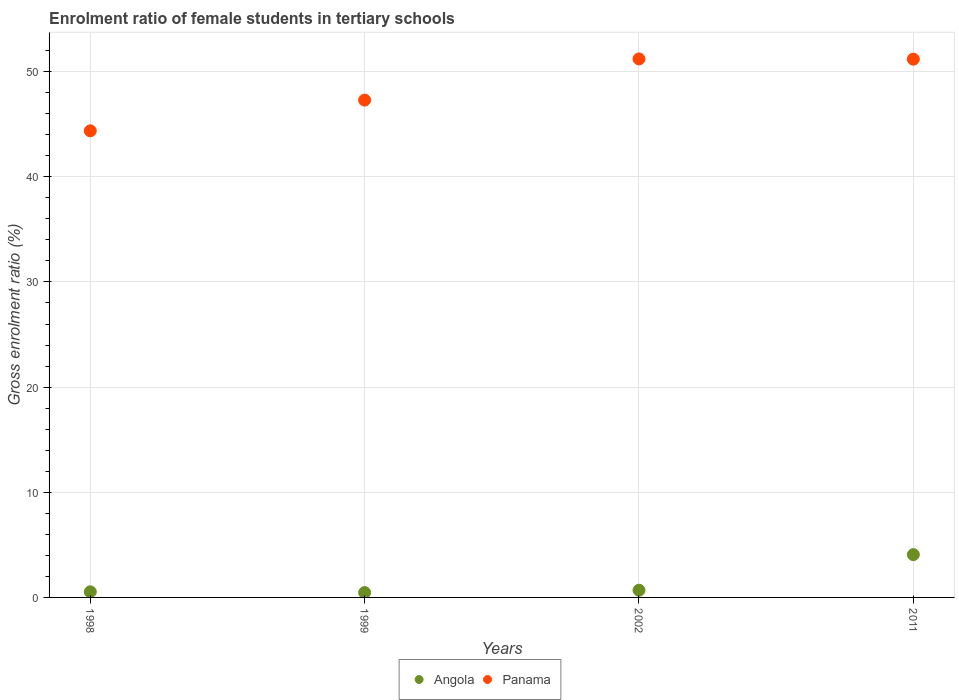How many different coloured dotlines are there?
Your answer should be very brief. 2. What is the enrolment ratio of female students in tertiary schools in Angola in 2011?
Offer a terse response. 4.07. Across all years, what is the maximum enrolment ratio of female students in tertiary schools in Panama?
Offer a very short reply. 51.21. Across all years, what is the minimum enrolment ratio of female students in tertiary schools in Panama?
Ensure brevity in your answer.  44.37. In which year was the enrolment ratio of female students in tertiary schools in Panama maximum?
Offer a terse response. 2002. What is the total enrolment ratio of female students in tertiary schools in Panama in the graph?
Ensure brevity in your answer.  194.06. What is the difference between the enrolment ratio of female students in tertiary schools in Panama in 1998 and that in 2011?
Offer a terse response. -6.81. What is the difference between the enrolment ratio of female students in tertiary schools in Panama in 2011 and the enrolment ratio of female students in tertiary schools in Angola in 1999?
Offer a terse response. 50.72. What is the average enrolment ratio of female students in tertiary schools in Angola per year?
Provide a short and direct response. 1.44. In the year 1999, what is the difference between the enrolment ratio of female students in tertiary schools in Panama and enrolment ratio of female students in tertiary schools in Angola?
Your answer should be very brief. 46.83. What is the ratio of the enrolment ratio of female students in tertiary schools in Panama in 1998 to that in 2011?
Offer a terse response. 0.87. Is the difference between the enrolment ratio of female students in tertiary schools in Panama in 1998 and 2011 greater than the difference between the enrolment ratio of female students in tertiary schools in Angola in 1998 and 2011?
Make the answer very short. No. What is the difference between the highest and the second highest enrolment ratio of female students in tertiary schools in Panama?
Your answer should be very brief. 0.02. What is the difference between the highest and the lowest enrolment ratio of female students in tertiary schools in Panama?
Keep it short and to the point. 6.84. In how many years, is the enrolment ratio of female students in tertiary schools in Angola greater than the average enrolment ratio of female students in tertiary schools in Angola taken over all years?
Keep it short and to the point. 1. Does the enrolment ratio of female students in tertiary schools in Panama monotonically increase over the years?
Provide a short and direct response. No. Is the enrolment ratio of female students in tertiary schools in Panama strictly less than the enrolment ratio of female students in tertiary schools in Angola over the years?
Your answer should be compact. No. How many dotlines are there?
Provide a succinct answer. 2. Does the graph contain grids?
Offer a terse response. Yes. How are the legend labels stacked?
Ensure brevity in your answer.  Horizontal. What is the title of the graph?
Make the answer very short. Enrolment ratio of female students in tertiary schools. Does "Italy" appear as one of the legend labels in the graph?
Keep it short and to the point. No. What is the Gross enrolment ratio (%) in Angola in 1998?
Keep it short and to the point. 0.53. What is the Gross enrolment ratio (%) in Panama in 1998?
Make the answer very short. 44.37. What is the Gross enrolment ratio (%) of Angola in 1999?
Your response must be concise. 0.46. What is the Gross enrolment ratio (%) in Panama in 1999?
Provide a short and direct response. 47.29. What is the Gross enrolment ratio (%) in Angola in 2002?
Offer a terse response. 0.68. What is the Gross enrolment ratio (%) of Panama in 2002?
Provide a succinct answer. 51.21. What is the Gross enrolment ratio (%) in Angola in 2011?
Keep it short and to the point. 4.07. What is the Gross enrolment ratio (%) of Panama in 2011?
Your answer should be compact. 51.19. Across all years, what is the maximum Gross enrolment ratio (%) in Angola?
Your answer should be compact. 4.07. Across all years, what is the maximum Gross enrolment ratio (%) in Panama?
Give a very brief answer. 51.21. Across all years, what is the minimum Gross enrolment ratio (%) of Angola?
Keep it short and to the point. 0.46. Across all years, what is the minimum Gross enrolment ratio (%) in Panama?
Give a very brief answer. 44.37. What is the total Gross enrolment ratio (%) in Angola in the graph?
Your response must be concise. 5.75. What is the total Gross enrolment ratio (%) in Panama in the graph?
Offer a terse response. 194.06. What is the difference between the Gross enrolment ratio (%) in Angola in 1998 and that in 1999?
Keep it short and to the point. 0.07. What is the difference between the Gross enrolment ratio (%) in Panama in 1998 and that in 1999?
Your answer should be very brief. -2.92. What is the difference between the Gross enrolment ratio (%) of Angola in 1998 and that in 2002?
Provide a short and direct response. -0.15. What is the difference between the Gross enrolment ratio (%) of Panama in 1998 and that in 2002?
Your answer should be very brief. -6.84. What is the difference between the Gross enrolment ratio (%) in Angola in 1998 and that in 2011?
Your answer should be compact. -3.53. What is the difference between the Gross enrolment ratio (%) of Panama in 1998 and that in 2011?
Your answer should be compact. -6.81. What is the difference between the Gross enrolment ratio (%) of Angola in 1999 and that in 2002?
Offer a very short reply. -0.22. What is the difference between the Gross enrolment ratio (%) of Panama in 1999 and that in 2002?
Your answer should be very brief. -3.91. What is the difference between the Gross enrolment ratio (%) in Angola in 1999 and that in 2011?
Offer a terse response. -3.61. What is the difference between the Gross enrolment ratio (%) of Panama in 1999 and that in 2011?
Provide a short and direct response. -3.89. What is the difference between the Gross enrolment ratio (%) in Angola in 2002 and that in 2011?
Provide a short and direct response. -3.38. What is the difference between the Gross enrolment ratio (%) of Panama in 2002 and that in 2011?
Offer a terse response. 0.02. What is the difference between the Gross enrolment ratio (%) in Angola in 1998 and the Gross enrolment ratio (%) in Panama in 1999?
Give a very brief answer. -46.76. What is the difference between the Gross enrolment ratio (%) in Angola in 1998 and the Gross enrolment ratio (%) in Panama in 2002?
Offer a terse response. -50.67. What is the difference between the Gross enrolment ratio (%) of Angola in 1998 and the Gross enrolment ratio (%) of Panama in 2011?
Your answer should be compact. -50.65. What is the difference between the Gross enrolment ratio (%) of Angola in 1999 and the Gross enrolment ratio (%) of Panama in 2002?
Make the answer very short. -50.75. What is the difference between the Gross enrolment ratio (%) of Angola in 1999 and the Gross enrolment ratio (%) of Panama in 2011?
Provide a short and direct response. -50.72. What is the difference between the Gross enrolment ratio (%) in Angola in 2002 and the Gross enrolment ratio (%) in Panama in 2011?
Keep it short and to the point. -50.5. What is the average Gross enrolment ratio (%) of Angola per year?
Your response must be concise. 1.44. What is the average Gross enrolment ratio (%) of Panama per year?
Offer a very short reply. 48.52. In the year 1998, what is the difference between the Gross enrolment ratio (%) of Angola and Gross enrolment ratio (%) of Panama?
Keep it short and to the point. -43.84. In the year 1999, what is the difference between the Gross enrolment ratio (%) of Angola and Gross enrolment ratio (%) of Panama?
Provide a short and direct response. -46.83. In the year 2002, what is the difference between the Gross enrolment ratio (%) in Angola and Gross enrolment ratio (%) in Panama?
Your answer should be very brief. -50.52. In the year 2011, what is the difference between the Gross enrolment ratio (%) in Angola and Gross enrolment ratio (%) in Panama?
Keep it short and to the point. -47.12. What is the ratio of the Gross enrolment ratio (%) of Angola in 1998 to that in 1999?
Make the answer very short. 1.16. What is the ratio of the Gross enrolment ratio (%) in Panama in 1998 to that in 1999?
Your answer should be very brief. 0.94. What is the ratio of the Gross enrolment ratio (%) of Angola in 1998 to that in 2002?
Your answer should be compact. 0.78. What is the ratio of the Gross enrolment ratio (%) in Panama in 1998 to that in 2002?
Your answer should be very brief. 0.87. What is the ratio of the Gross enrolment ratio (%) of Angola in 1998 to that in 2011?
Offer a very short reply. 0.13. What is the ratio of the Gross enrolment ratio (%) in Panama in 1998 to that in 2011?
Offer a terse response. 0.87. What is the ratio of the Gross enrolment ratio (%) of Angola in 1999 to that in 2002?
Offer a terse response. 0.68. What is the ratio of the Gross enrolment ratio (%) of Panama in 1999 to that in 2002?
Your answer should be compact. 0.92. What is the ratio of the Gross enrolment ratio (%) in Angola in 1999 to that in 2011?
Give a very brief answer. 0.11. What is the ratio of the Gross enrolment ratio (%) of Panama in 1999 to that in 2011?
Ensure brevity in your answer.  0.92. What is the ratio of the Gross enrolment ratio (%) of Angola in 2002 to that in 2011?
Provide a short and direct response. 0.17. What is the ratio of the Gross enrolment ratio (%) of Panama in 2002 to that in 2011?
Keep it short and to the point. 1. What is the difference between the highest and the second highest Gross enrolment ratio (%) of Angola?
Offer a terse response. 3.38. What is the difference between the highest and the second highest Gross enrolment ratio (%) in Panama?
Offer a very short reply. 0.02. What is the difference between the highest and the lowest Gross enrolment ratio (%) of Angola?
Make the answer very short. 3.61. What is the difference between the highest and the lowest Gross enrolment ratio (%) in Panama?
Make the answer very short. 6.84. 